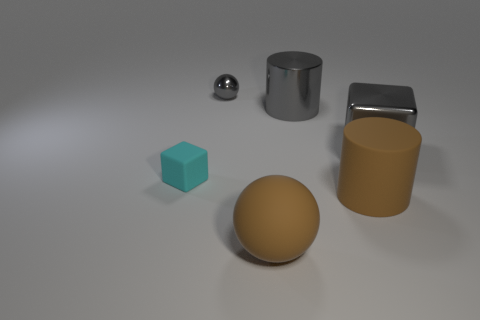How many things are tiny objects that are in front of the metal block or rubber things on the right side of the gray shiny ball? Upon reviewing the image, it appears that there are no tiny objects directly in front of the metal block, and there are no distinctly 'rubber' things visible to make a definitive identification. However, if we consider anything smaller than the metal block and to the right of the gray shiny ball as 'tiny,' we could consider the small sphere as one such object based on its relative size and position. Thus, we could say there's at least one tiny object according to these parameters. 